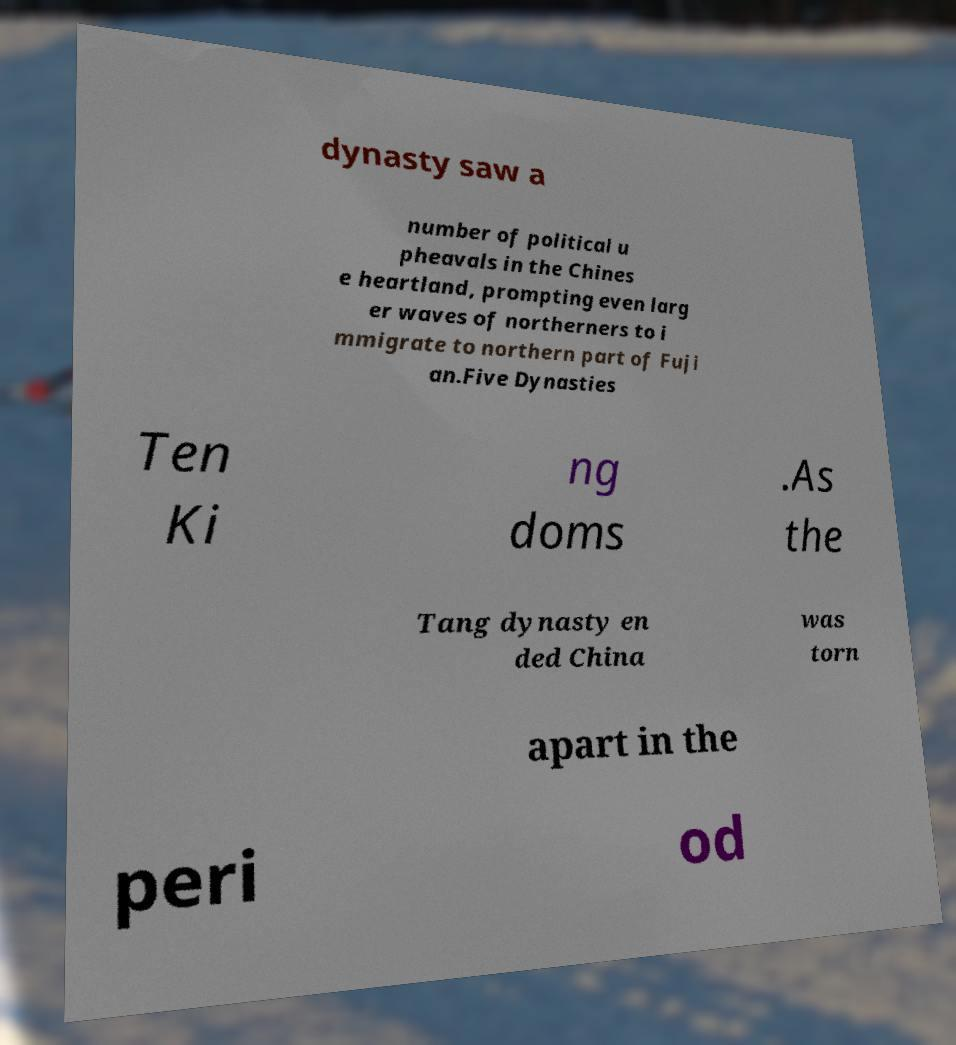There's text embedded in this image that I need extracted. Can you transcribe it verbatim? dynasty saw a number of political u pheavals in the Chines e heartland, prompting even larg er waves of northerners to i mmigrate to northern part of Fuji an.Five Dynasties Ten Ki ng doms .As the Tang dynasty en ded China was torn apart in the peri od 